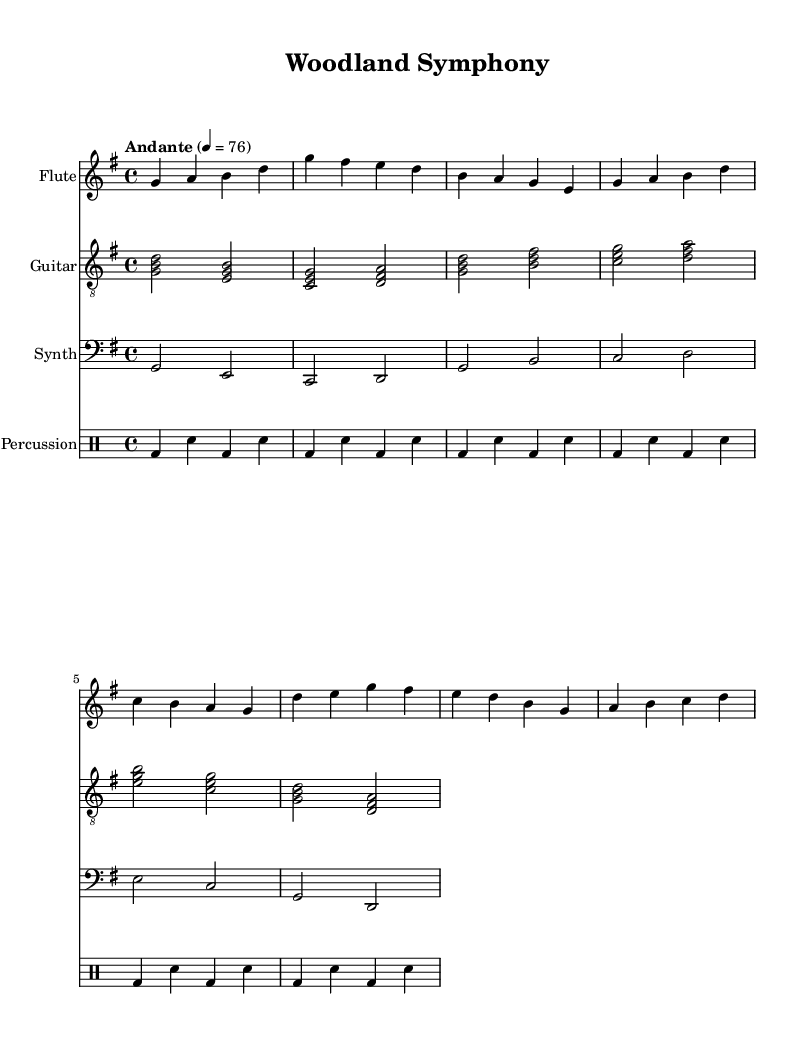What is the key signature of this music? The key signature is G major, which has one sharp (F#). This can be identified by looking at the key signature at the beginning of the staff.
Answer: G major What is the time signature of this piece? The time signature is 4/4, which is indicated right after the key signature. This means there are four beats in each measure.
Answer: 4/4 What is the tempo marking for this composition? The tempo marking is "Andante," indicating a moderate pace. This is found in the tempo aspect near the beginning of the score.
Answer: Andante How many measures does the flute part have? The flute part contains 8 measures. This is determined by counting the groups of notes separated by vertical bars (measure lines) in the written section for the flute.
Answer: 8 Which instrument plays the lowest range? The synth plays the lowest range in the score since it is notated on the bass clef, indicating lower pitches compared to the treble clefs of flute and guitar.
Answer: Synth How does the percussion pattern compare to the flute melody? The percussion pattern is more rhythmic and steady, while the flute melody is melodic and flowing. This can be understood by observing the consistent drum hits versus the varying notes in the flute part.
Answer: Steady vs. melodic What traditional elements are combined in this fusion piece? The fusion piece combines ambient sounds with traditional instruments, specifically flute and guitar mimicking bird calls, as highlighted by the style and instrumentation used in the score.
Answer: Ambient sounds with traditional instruments 